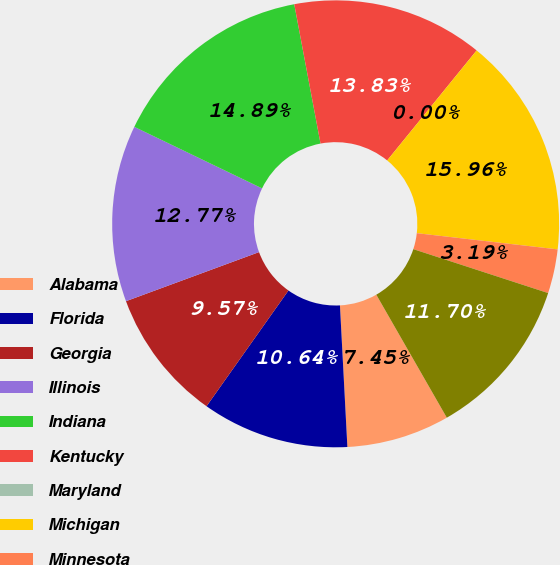<chart> <loc_0><loc_0><loc_500><loc_500><pie_chart><fcel>Alabama<fcel>Florida<fcel>Georgia<fcel>Illinois<fcel>Indiana<fcel>Kentucky<fcel>Maryland<fcel>Michigan<fcel>Minnesota<fcel>North Carolina<nl><fcel>7.45%<fcel>10.64%<fcel>9.57%<fcel>12.77%<fcel>14.89%<fcel>13.83%<fcel>0.0%<fcel>15.96%<fcel>3.19%<fcel>11.7%<nl></chart> 